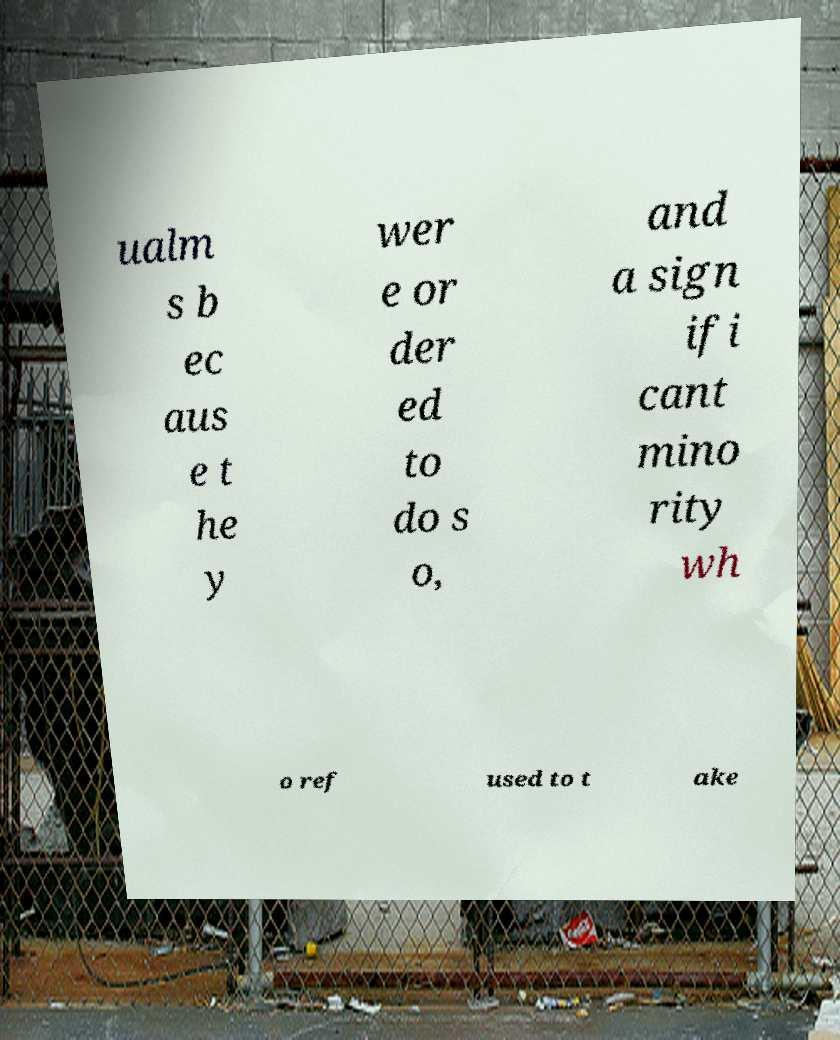What messages or text are displayed in this image? I need them in a readable, typed format. ualm s b ec aus e t he y wer e or der ed to do s o, and a sign ifi cant mino rity wh o ref used to t ake 